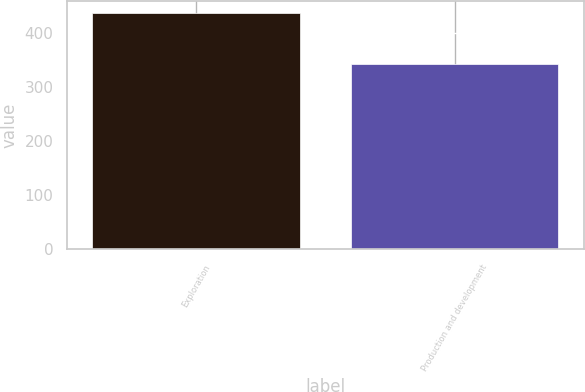<chart> <loc_0><loc_0><loc_500><loc_500><bar_chart><fcel>Exploration<fcel>Production and development<nl><fcel>438<fcel>343<nl></chart> 